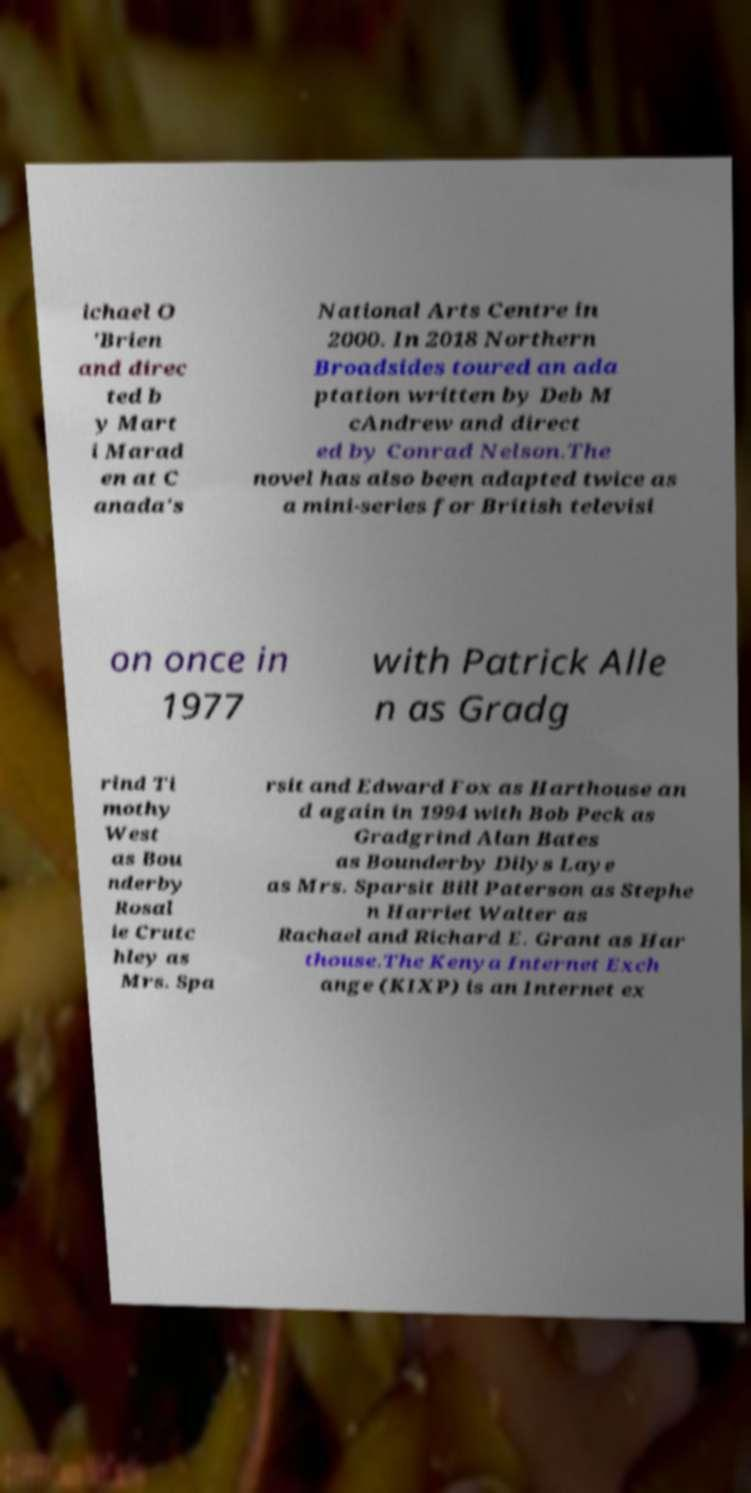Can you read and provide the text displayed in the image?This photo seems to have some interesting text. Can you extract and type it out for me? ichael O 'Brien and direc ted b y Mart i Marad en at C anada's National Arts Centre in 2000. In 2018 Northern Broadsides toured an ada ptation written by Deb M cAndrew and direct ed by Conrad Nelson.The novel has also been adapted twice as a mini-series for British televisi on once in 1977 with Patrick Alle n as Gradg rind Ti mothy West as Bou nderby Rosal ie Crutc hley as Mrs. Spa rsit and Edward Fox as Harthouse an d again in 1994 with Bob Peck as Gradgrind Alan Bates as Bounderby Dilys Laye as Mrs. Sparsit Bill Paterson as Stephe n Harriet Walter as Rachael and Richard E. Grant as Har thouse.The Kenya Internet Exch ange (KIXP) is an Internet ex 